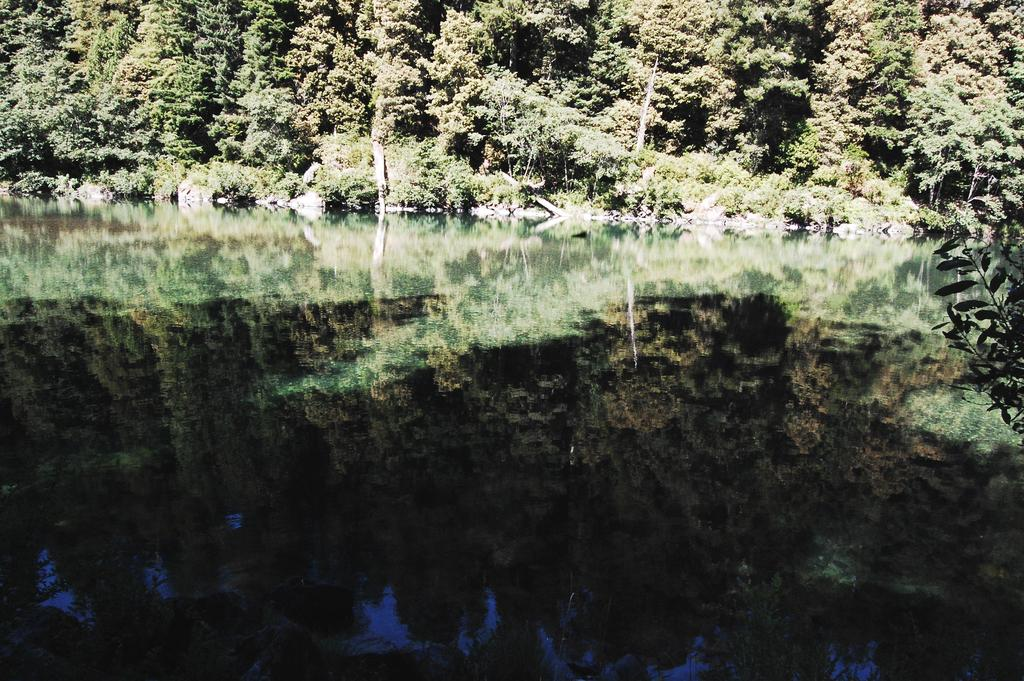What type of natural feature is at the bottom of the image? There is a river at the bottom of the image. What can be seen on the right side of the image? There is a plant on the right side of the image. What type of vegetation is at the top of the image? There are trees at the top of the image. How many mice are sitting on the head of the person in the image? There is no person or mice present in the image. What type of building can be seen in the image? There is no building present in the image; it features a river, a plant, and trees. 